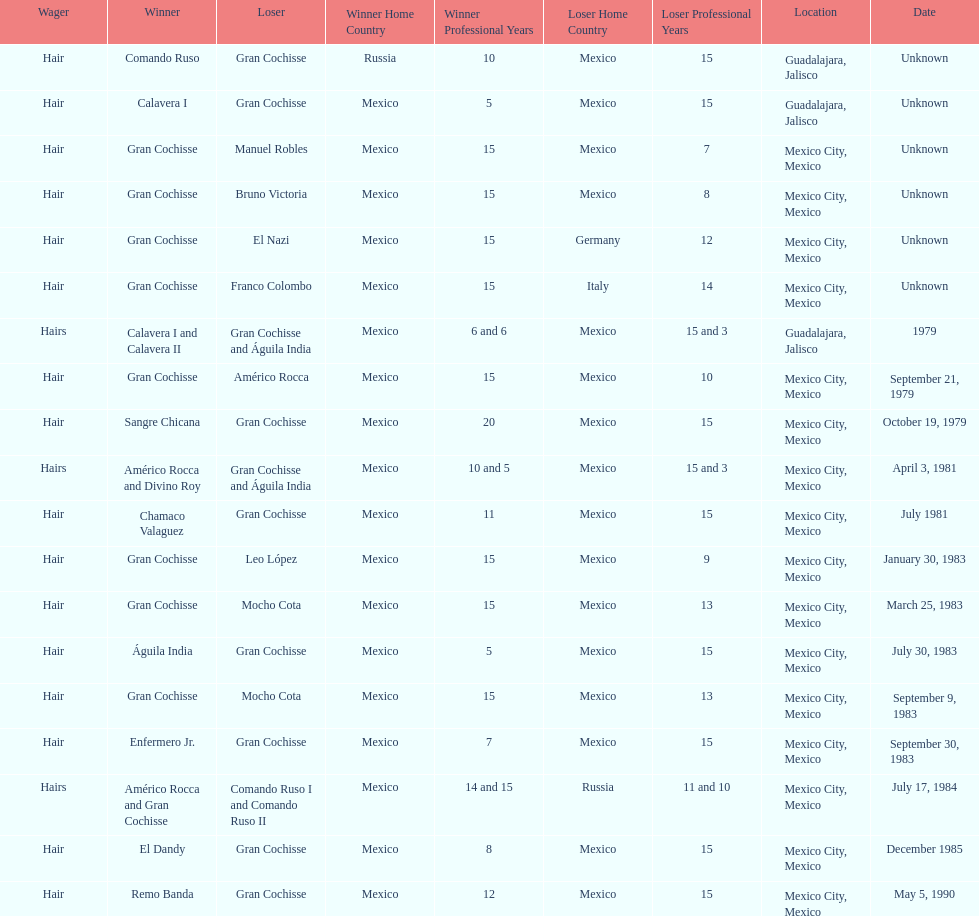What was the number of losses gran cochisse had against el dandy? 1. 